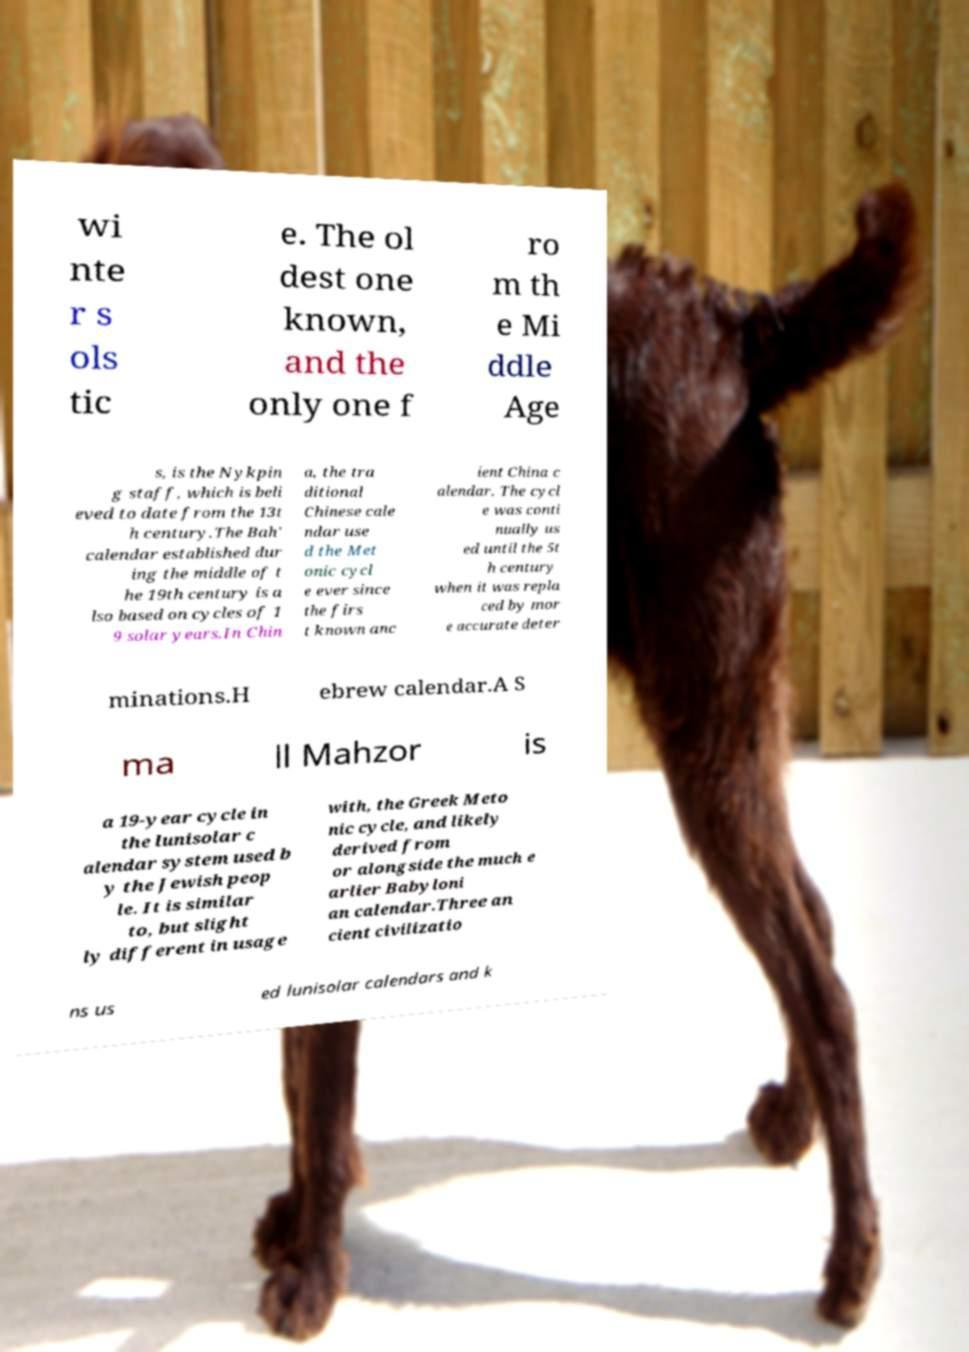Can you read and provide the text displayed in the image?This photo seems to have some interesting text. Can you extract and type it out for me? wi nte r s ols tic e. The ol dest one known, and the only one f ro m th e Mi ddle Age s, is the Nykpin g staff, which is beli eved to date from the 13t h century.The Bah' calendar established dur ing the middle of t he 19th century is a lso based on cycles of 1 9 solar years.In Chin a, the tra ditional Chinese cale ndar use d the Met onic cycl e ever since the firs t known anc ient China c alendar. The cycl e was conti nually us ed until the 5t h century when it was repla ced by mor e accurate deter minations.H ebrew calendar.A S ma ll Mahzor is a 19-year cycle in the lunisolar c alendar system used b y the Jewish peop le. It is similar to, but slight ly different in usage with, the Greek Meto nic cycle, and likely derived from or alongside the much e arlier Babyloni an calendar.Three an cient civilizatio ns us ed lunisolar calendars and k 